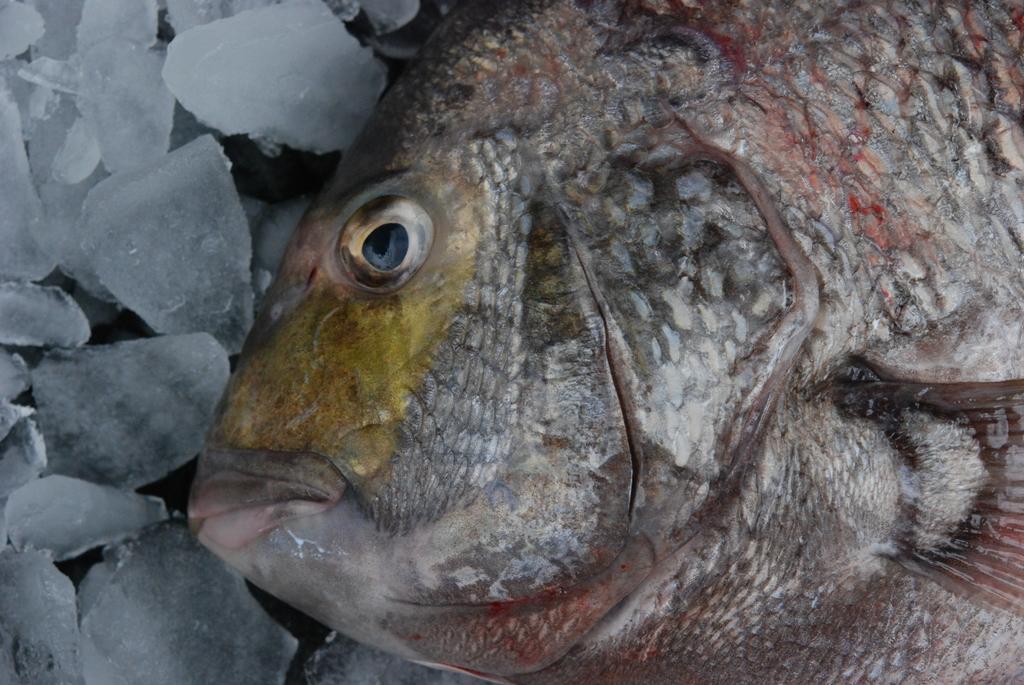Describe this image in one or two sentences. In the foreground of this image, there is a truncated fish on the ice. 